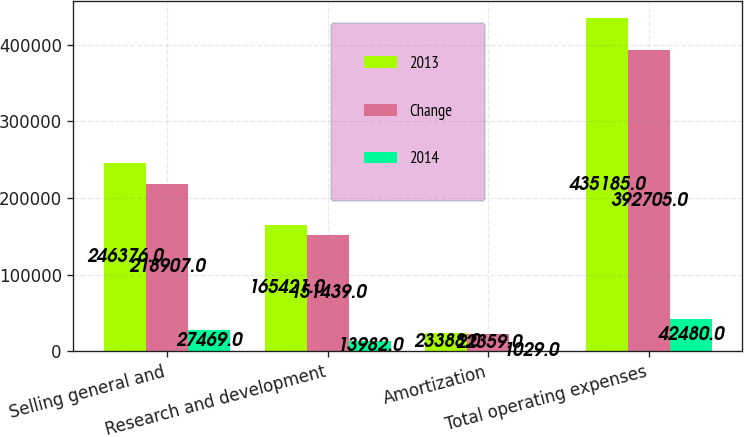Convert chart. <chart><loc_0><loc_0><loc_500><loc_500><stacked_bar_chart><ecel><fcel>Selling general and<fcel>Research and development<fcel>Amortization<fcel>Total operating expenses<nl><fcel>2013<fcel>246376<fcel>165421<fcel>23388<fcel>435185<nl><fcel>Change<fcel>218907<fcel>151439<fcel>22359<fcel>392705<nl><fcel>2014<fcel>27469<fcel>13982<fcel>1029<fcel>42480<nl></chart> 